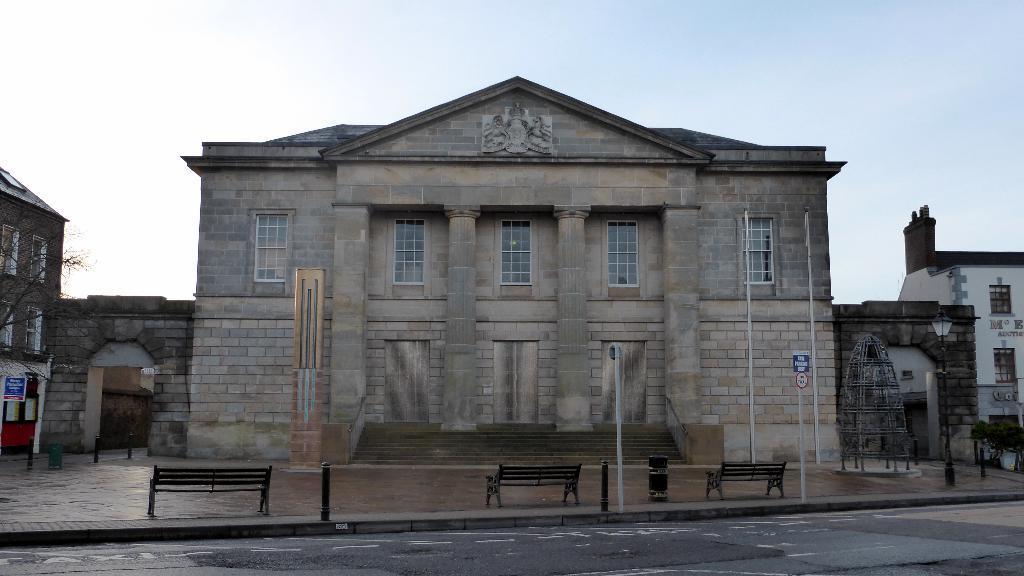How would you summarize this image in a sentence or two? In this image we can see a building and in front of it there is a staircase, poles, sign boards and benches, on the right side of the image there is a building, object, street light and plants, on the left side of the image there are buildings, trees and a board. 